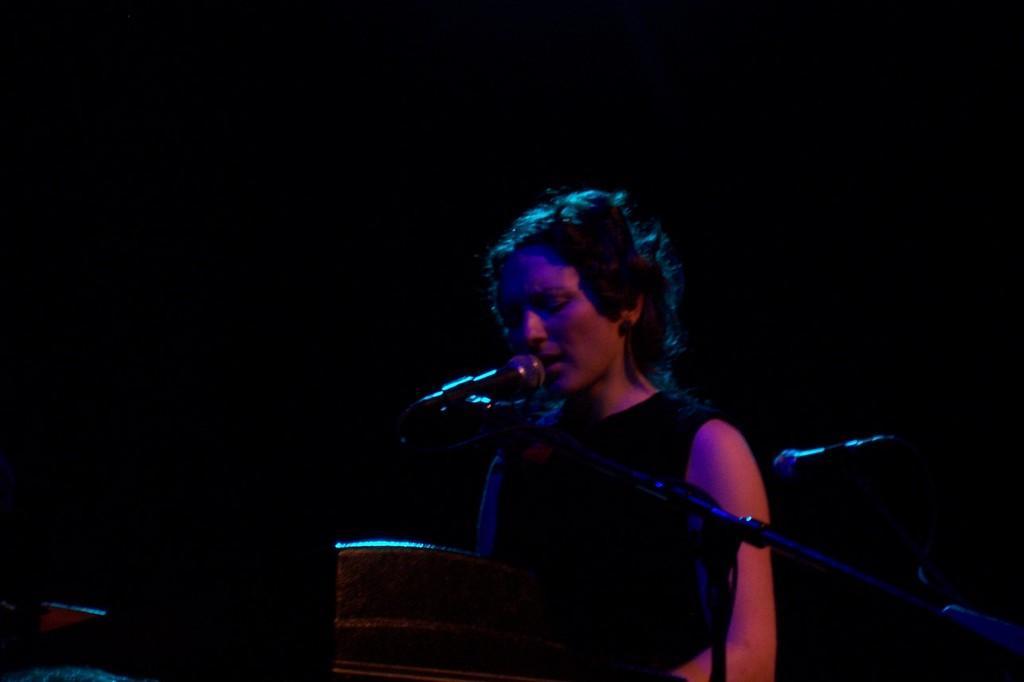Describe this image in one or two sentences. In this image, in the middle, we can see a woman standing and singing in front of a microphone. On the right side, we can see two microphones. In the background, we can see a black color. 